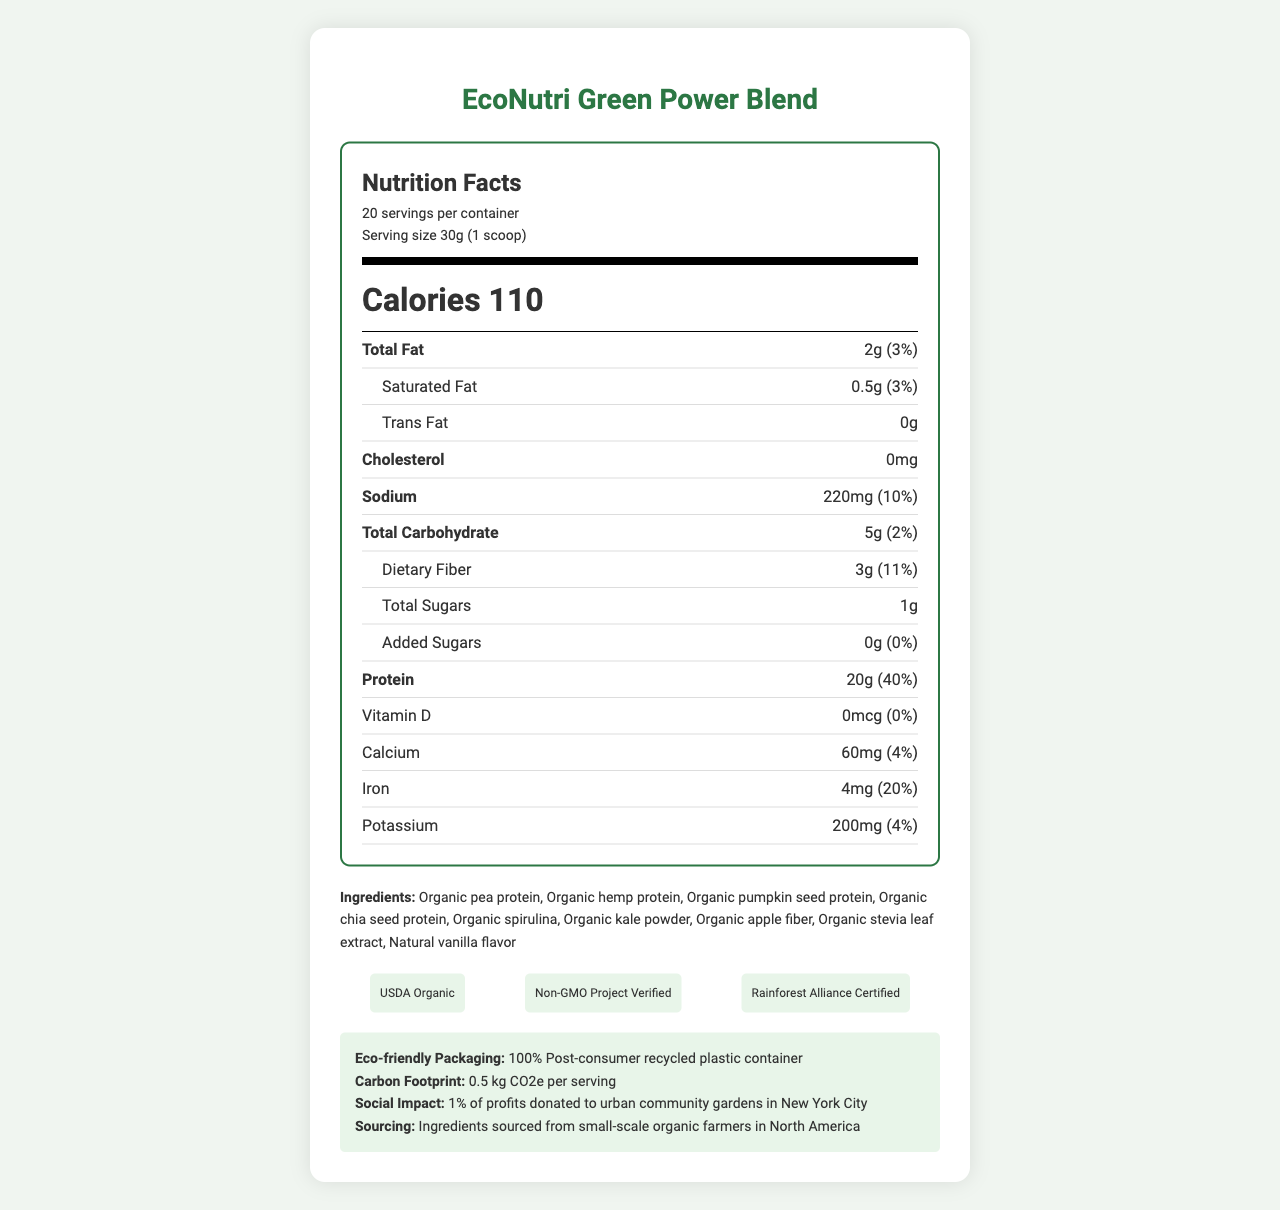What is the serving size of the EcoNutri Green Power Blend? The serving size is clearly stated in the "serving-info" section under the "Nutrition Facts" header.
Answer: 30g (1 scoop) How many calories are in a single serving? The calorie information is prominently displayed in bold text under the "calorie-info" section.
Answer: 110 Which certifications does this product have? The certifications are listed in the "certifications" section under the ingredients.
Answer: USDA Organic, Non-GMO Project Verified, Rainforest Alliance Certified What is the total fat per serving and its daily value percentage? The total fat information is provided in the "nutrient-row" section with the amount and daily value percentage.
Answer: 2g (3%) How much protein is in each serving? The protein content per serving is specified under the "nutrient-row" section.
Answer: 20g (40%) What is the main flavor profile of the EcoNutri Green Power Blend? The flavor profile is clearly mentioned in the provided data about the product description.
Answer: Subtle vanilla with earthy undertones Multiple-choice: What amount of sodium is in each serving? A. 110mg B. 150mg C. 220mg D. 300mg The sodium content is listed in the "nutrient-row" section.
Answer: C. 220mg Multiple-choice: Which one of the following is NOT included as an ingredient? A. Organic apple fiber B. Organic kale powder C. Organic pumpkin seed protein D. Organic wheat protein Organic wheat protein is not listed in the "ingredients" section.
Answer: D. Organic wheat protein Is the product suitable for someone with gluten intolerance? The product is listed as gluten-free under the "dietary_compatibility" section.
Answer: Yes Does the product have any added sugars? The added sugars information is clearly shown as "0g (0%)" in the "sub-nutrient" section.
Answer: No, it has 0g of added sugars (0%) What is the social impact mentioned for this product? The social impact is detailed in the "eco-info" section.
Answer: 1% of profits donated to urban community gardens in New York City Can you determine the cost per container from the document? The document does not provide any details regarding the cost of the product.
Answer: Not enough information Briefly summarize the main ideas of the document. This summary extracts the key points about the nutrition facts, certifications, ingredients, and the product's social and environmental benefits from the document.
Answer: The document provides an overview of the nutrition facts, ingredients, certifications, eco-friendly packaging, and social impact of the EcoNutri Green Power Blend. It emphasizes its organic, non-GMO, and sustainable ingredients, and lists its nutrient content for a 30g serving. 